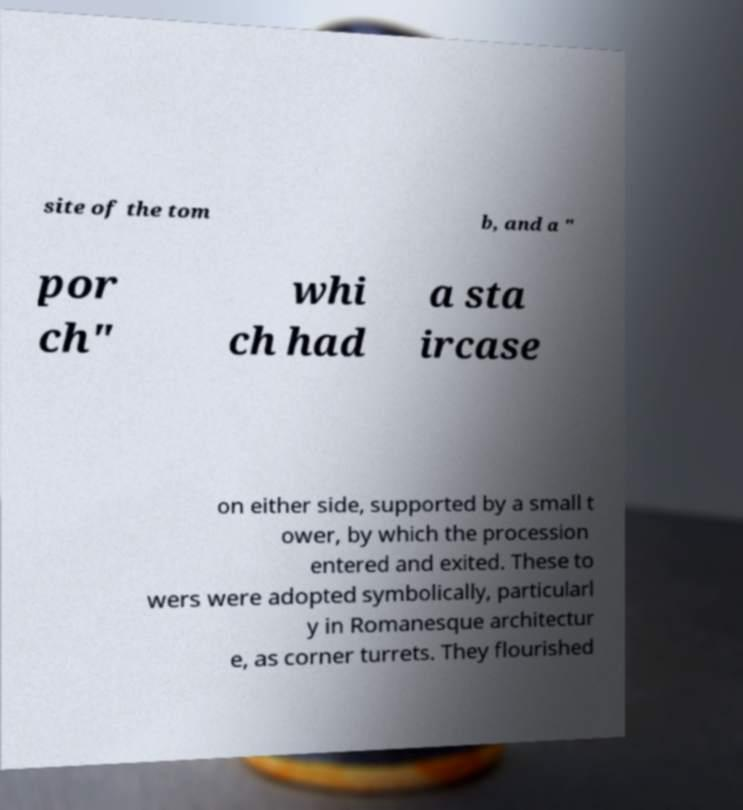Can you accurately transcribe the text from the provided image for me? site of the tom b, and a " por ch" whi ch had a sta ircase on either side, supported by a small t ower, by which the procession entered and exited. These to wers were adopted symbolically, particularl y in Romanesque architectur e, as corner turrets. They flourished 